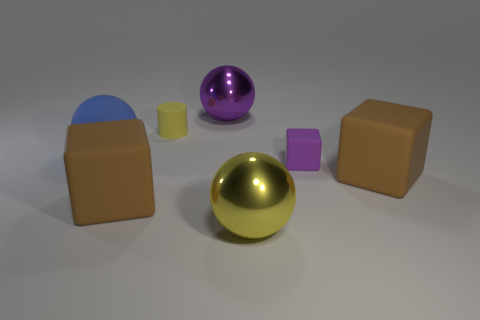How many other big shiny things are the same shape as the big blue thing? There are two other large shiny objects that share the same spherical shape as the big blue object: a purple sphere and a gold sphere. 